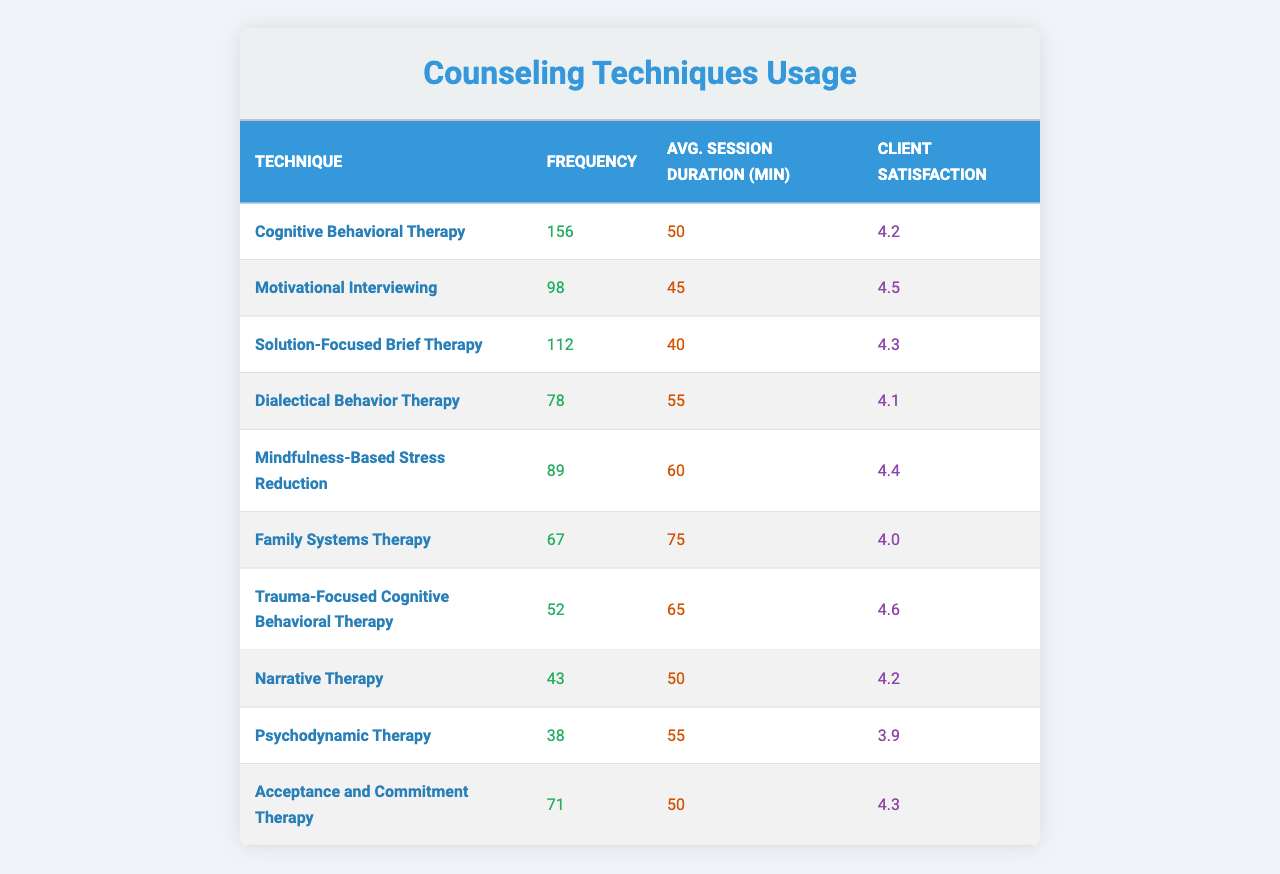What is the most frequently used counseling technique? By reviewing the 'Frequency' column in the table, I see that 'Cognitive Behavioral Therapy' has the highest frequency of 156 sessions compared to other techniques.
Answer: Cognitive Behavioral Therapy Which counseling technique has the highest client satisfaction rating? Looking at the 'Client Satisfaction' column, 'Trauma-Focused Cognitive Behavioral Therapy' has the highest rating of 4.6 among all the techniques.
Answer: Trauma-Focused Cognitive Behavioral Therapy How many times was 'Family Systems Therapy' used? The 'Frequency' column indicates that 'Family Systems Therapy' was used 67 times throughout the year.
Answer: 67 What is the average session duration for 'Mindfulness-Based Stress Reduction'? The 'Avg. Session Duration' column shows that 'Mindfulness-Based Stress Reduction' sessions lasted an average of 60 minutes.
Answer: 60 Calculate the total frequency of all counseling techniques combined. By summing the frequencies listed, 156 + 98 + 112 + 78 + 89 + 67 + 52 + 43 + 38 + 71 equals a total of 823 sessions.
Answer: 823 What is the difference in client satisfaction between 'Motivational Interviewing' and 'Psychodynamic Therapy'? From the 'Client Satisfaction' column, 'Motivational Interviewing' has a rating of 4.5, while 'Psychodynamic Therapy' has a rating of 3.9. The difference is 4.5 - 3.9 = 0.6.
Answer: 0.6 Which two techniques had an average session duration of more than 50 minutes? By inspecting the 'Avg. Session Duration' column, 'Dialectical Behavior Therapy' (55 minutes) and 'Family Systems Therapy' (75 minutes) both exceed 50 minutes.
Answer: Dialectical Behavior Therapy and Family Systems Therapy Is the client satisfaction rating for 'Acceptance and Commitment Therapy' greater than 4.5? Checking the 'Client Satisfaction' rating, 'Acceptance and Commitment Therapy' has a score of 4.3, which is less than 4.5.
Answer: No How does the average session duration for 'Cognitive Behavioral Therapy' compare to 'Solution-Focused Brief Therapy'? The average duration for 'Cognitive Behavioral Therapy' is 50 minutes, while 'Solution-Focused Brief Therapy' is 40 minutes. Therefore, Cognitive Behavioral Therapy sessions are longer by 10 minutes.
Answer: Longer by 10 minutes Which counseling technique had the lowest frequency of use? The 'Frequency' column shows 'Psychodynamic Therapy' with the lowest frequency of 38 sessions, making it the least used technique.
Answer: Psychodynamic Therapy 